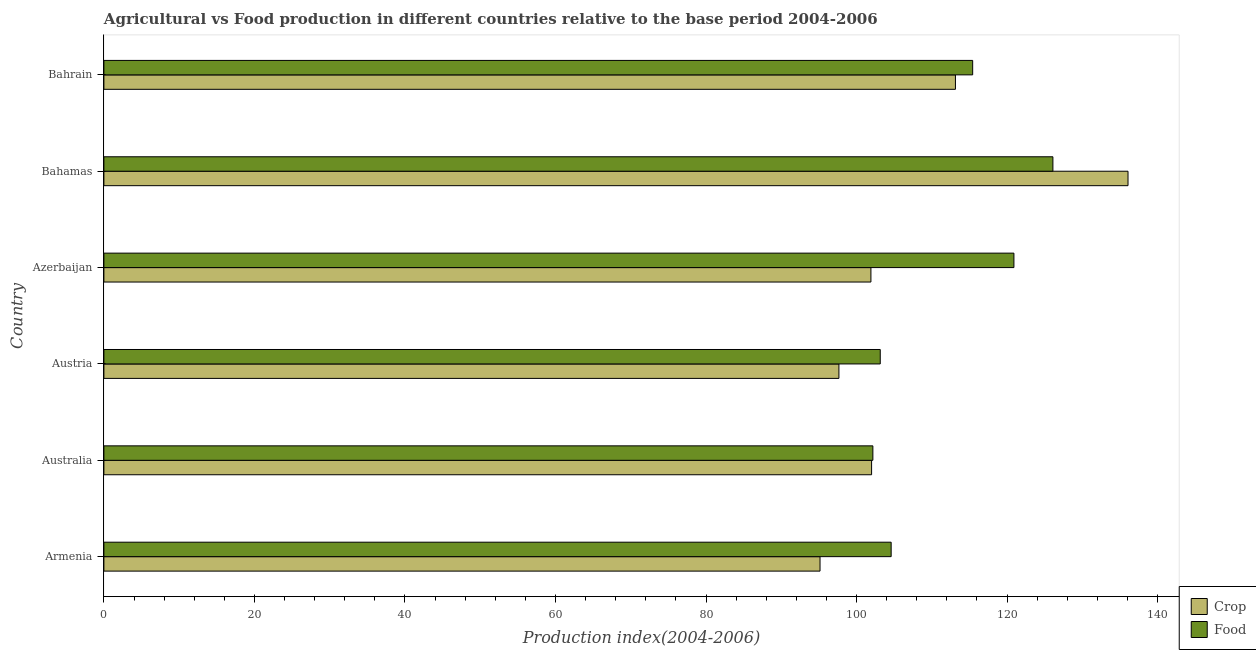Are the number of bars per tick equal to the number of legend labels?
Provide a short and direct response. Yes. Are the number of bars on each tick of the Y-axis equal?
Your answer should be compact. Yes. How many bars are there on the 1st tick from the bottom?
Your answer should be very brief. 2. What is the label of the 3rd group of bars from the top?
Your answer should be compact. Azerbaijan. In how many cases, is the number of bars for a given country not equal to the number of legend labels?
Ensure brevity in your answer.  0. What is the food production index in Austria?
Give a very brief answer. 103.15. Across all countries, what is the maximum food production index?
Provide a succinct answer. 126.09. Across all countries, what is the minimum food production index?
Offer a terse response. 102.17. In which country was the crop production index maximum?
Your answer should be very brief. Bahamas. What is the total food production index in the graph?
Your answer should be compact. 672.35. What is the difference between the food production index in Armenia and that in Azerbaijan?
Make the answer very short. -16.31. What is the difference between the food production index in Austria and the crop production index in Bahamas?
Keep it short and to the point. -32.92. What is the average food production index per country?
Provide a succinct answer. 112.06. What is the difference between the crop production index and food production index in Australia?
Ensure brevity in your answer.  -0.17. What is the ratio of the food production index in Azerbaijan to that in Bahrain?
Your answer should be compact. 1.05. Is the food production index in Austria less than that in Bahamas?
Your response must be concise. Yes. Is the difference between the food production index in Azerbaijan and Bahamas greater than the difference between the crop production index in Azerbaijan and Bahamas?
Your answer should be compact. Yes. What is the difference between the highest and the second highest crop production index?
Make the answer very short. 22.93. What is the difference between the highest and the lowest crop production index?
Give a very brief answer. 40.92. What does the 2nd bar from the top in Bahrain represents?
Offer a terse response. Crop. What does the 1st bar from the bottom in Armenia represents?
Offer a terse response. Crop. How many countries are there in the graph?
Your answer should be compact. 6. What is the difference between two consecutive major ticks on the X-axis?
Make the answer very short. 20. Are the values on the major ticks of X-axis written in scientific E-notation?
Make the answer very short. No. Does the graph contain any zero values?
Provide a succinct answer. No. Does the graph contain grids?
Offer a terse response. No. How are the legend labels stacked?
Offer a very short reply. Vertical. What is the title of the graph?
Ensure brevity in your answer.  Agricultural vs Food production in different countries relative to the base period 2004-2006. Does "Total Population" appear as one of the legend labels in the graph?
Provide a succinct answer. No. What is the label or title of the X-axis?
Offer a very short reply. Production index(2004-2006). What is the Production index(2004-2006) in Crop in Armenia?
Your answer should be compact. 95.15. What is the Production index(2004-2006) of Food in Armenia?
Ensure brevity in your answer.  104.6. What is the Production index(2004-2006) of Crop in Australia?
Keep it short and to the point. 102. What is the Production index(2004-2006) of Food in Australia?
Make the answer very short. 102.17. What is the Production index(2004-2006) in Crop in Austria?
Your answer should be compact. 97.66. What is the Production index(2004-2006) in Food in Austria?
Offer a terse response. 103.15. What is the Production index(2004-2006) in Crop in Azerbaijan?
Offer a terse response. 101.91. What is the Production index(2004-2006) of Food in Azerbaijan?
Give a very brief answer. 120.91. What is the Production index(2004-2006) of Crop in Bahamas?
Keep it short and to the point. 136.07. What is the Production index(2004-2006) in Food in Bahamas?
Make the answer very short. 126.09. What is the Production index(2004-2006) of Crop in Bahrain?
Your answer should be very brief. 113.14. What is the Production index(2004-2006) of Food in Bahrain?
Your answer should be compact. 115.43. Across all countries, what is the maximum Production index(2004-2006) of Crop?
Make the answer very short. 136.07. Across all countries, what is the maximum Production index(2004-2006) in Food?
Provide a short and direct response. 126.09. Across all countries, what is the minimum Production index(2004-2006) of Crop?
Offer a terse response. 95.15. Across all countries, what is the minimum Production index(2004-2006) of Food?
Make the answer very short. 102.17. What is the total Production index(2004-2006) in Crop in the graph?
Offer a terse response. 645.93. What is the total Production index(2004-2006) of Food in the graph?
Your response must be concise. 672.35. What is the difference between the Production index(2004-2006) of Crop in Armenia and that in Australia?
Your response must be concise. -6.85. What is the difference between the Production index(2004-2006) of Food in Armenia and that in Australia?
Offer a very short reply. 2.43. What is the difference between the Production index(2004-2006) in Crop in Armenia and that in Austria?
Provide a succinct answer. -2.51. What is the difference between the Production index(2004-2006) in Food in Armenia and that in Austria?
Your answer should be very brief. 1.45. What is the difference between the Production index(2004-2006) in Crop in Armenia and that in Azerbaijan?
Your answer should be compact. -6.76. What is the difference between the Production index(2004-2006) of Food in Armenia and that in Azerbaijan?
Provide a short and direct response. -16.31. What is the difference between the Production index(2004-2006) of Crop in Armenia and that in Bahamas?
Your answer should be very brief. -40.92. What is the difference between the Production index(2004-2006) of Food in Armenia and that in Bahamas?
Your answer should be very brief. -21.49. What is the difference between the Production index(2004-2006) of Crop in Armenia and that in Bahrain?
Your response must be concise. -17.99. What is the difference between the Production index(2004-2006) of Food in Armenia and that in Bahrain?
Your response must be concise. -10.83. What is the difference between the Production index(2004-2006) of Crop in Australia and that in Austria?
Offer a terse response. 4.34. What is the difference between the Production index(2004-2006) of Food in Australia and that in Austria?
Make the answer very short. -0.98. What is the difference between the Production index(2004-2006) in Crop in Australia and that in Azerbaijan?
Make the answer very short. 0.09. What is the difference between the Production index(2004-2006) in Food in Australia and that in Azerbaijan?
Your answer should be compact. -18.74. What is the difference between the Production index(2004-2006) of Crop in Australia and that in Bahamas?
Give a very brief answer. -34.07. What is the difference between the Production index(2004-2006) of Food in Australia and that in Bahamas?
Your answer should be compact. -23.92. What is the difference between the Production index(2004-2006) in Crop in Australia and that in Bahrain?
Your answer should be compact. -11.14. What is the difference between the Production index(2004-2006) in Food in Australia and that in Bahrain?
Provide a succinct answer. -13.26. What is the difference between the Production index(2004-2006) in Crop in Austria and that in Azerbaijan?
Ensure brevity in your answer.  -4.25. What is the difference between the Production index(2004-2006) of Food in Austria and that in Azerbaijan?
Offer a terse response. -17.76. What is the difference between the Production index(2004-2006) of Crop in Austria and that in Bahamas?
Give a very brief answer. -38.41. What is the difference between the Production index(2004-2006) in Food in Austria and that in Bahamas?
Your answer should be compact. -22.94. What is the difference between the Production index(2004-2006) of Crop in Austria and that in Bahrain?
Provide a succinct answer. -15.48. What is the difference between the Production index(2004-2006) of Food in Austria and that in Bahrain?
Offer a terse response. -12.28. What is the difference between the Production index(2004-2006) of Crop in Azerbaijan and that in Bahamas?
Provide a succinct answer. -34.16. What is the difference between the Production index(2004-2006) in Food in Azerbaijan and that in Bahamas?
Ensure brevity in your answer.  -5.18. What is the difference between the Production index(2004-2006) of Crop in Azerbaijan and that in Bahrain?
Offer a very short reply. -11.23. What is the difference between the Production index(2004-2006) in Food in Azerbaijan and that in Bahrain?
Your answer should be very brief. 5.48. What is the difference between the Production index(2004-2006) of Crop in Bahamas and that in Bahrain?
Offer a very short reply. 22.93. What is the difference between the Production index(2004-2006) in Food in Bahamas and that in Bahrain?
Keep it short and to the point. 10.66. What is the difference between the Production index(2004-2006) of Crop in Armenia and the Production index(2004-2006) of Food in Australia?
Your answer should be compact. -7.02. What is the difference between the Production index(2004-2006) in Crop in Armenia and the Production index(2004-2006) in Food in Azerbaijan?
Keep it short and to the point. -25.76. What is the difference between the Production index(2004-2006) in Crop in Armenia and the Production index(2004-2006) in Food in Bahamas?
Make the answer very short. -30.94. What is the difference between the Production index(2004-2006) of Crop in Armenia and the Production index(2004-2006) of Food in Bahrain?
Give a very brief answer. -20.28. What is the difference between the Production index(2004-2006) in Crop in Australia and the Production index(2004-2006) in Food in Austria?
Your response must be concise. -1.15. What is the difference between the Production index(2004-2006) in Crop in Australia and the Production index(2004-2006) in Food in Azerbaijan?
Provide a succinct answer. -18.91. What is the difference between the Production index(2004-2006) of Crop in Australia and the Production index(2004-2006) of Food in Bahamas?
Your answer should be very brief. -24.09. What is the difference between the Production index(2004-2006) of Crop in Australia and the Production index(2004-2006) of Food in Bahrain?
Keep it short and to the point. -13.43. What is the difference between the Production index(2004-2006) of Crop in Austria and the Production index(2004-2006) of Food in Azerbaijan?
Offer a terse response. -23.25. What is the difference between the Production index(2004-2006) in Crop in Austria and the Production index(2004-2006) in Food in Bahamas?
Your answer should be compact. -28.43. What is the difference between the Production index(2004-2006) of Crop in Austria and the Production index(2004-2006) of Food in Bahrain?
Give a very brief answer. -17.77. What is the difference between the Production index(2004-2006) of Crop in Azerbaijan and the Production index(2004-2006) of Food in Bahamas?
Give a very brief answer. -24.18. What is the difference between the Production index(2004-2006) of Crop in Azerbaijan and the Production index(2004-2006) of Food in Bahrain?
Make the answer very short. -13.52. What is the difference between the Production index(2004-2006) in Crop in Bahamas and the Production index(2004-2006) in Food in Bahrain?
Your response must be concise. 20.64. What is the average Production index(2004-2006) of Crop per country?
Your response must be concise. 107.66. What is the average Production index(2004-2006) in Food per country?
Make the answer very short. 112.06. What is the difference between the Production index(2004-2006) in Crop and Production index(2004-2006) in Food in Armenia?
Your answer should be very brief. -9.45. What is the difference between the Production index(2004-2006) in Crop and Production index(2004-2006) in Food in Australia?
Keep it short and to the point. -0.17. What is the difference between the Production index(2004-2006) of Crop and Production index(2004-2006) of Food in Austria?
Your answer should be very brief. -5.49. What is the difference between the Production index(2004-2006) of Crop and Production index(2004-2006) of Food in Azerbaijan?
Ensure brevity in your answer.  -19. What is the difference between the Production index(2004-2006) of Crop and Production index(2004-2006) of Food in Bahamas?
Your answer should be very brief. 9.98. What is the difference between the Production index(2004-2006) in Crop and Production index(2004-2006) in Food in Bahrain?
Your response must be concise. -2.29. What is the ratio of the Production index(2004-2006) in Crop in Armenia to that in Australia?
Give a very brief answer. 0.93. What is the ratio of the Production index(2004-2006) of Food in Armenia to that in Australia?
Provide a succinct answer. 1.02. What is the ratio of the Production index(2004-2006) of Crop in Armenia to that in Austria?
Offer a very short reply. 0.97. What is the ratio of the Production index(2004-2006) of Food in Armenia to that in Austria?
Your response must be concise. 1.01. What is the ratio of the Production index(2004-2006) in Crop in Armenia to that in Azerbaijan?
Your answer should be very brief. 0.93. What is the ratio of the Production index(2004-2006) in Food in Armenia to that in Azerbaijan?
Provide a succinct answer. 0.87. What is the ratio of the Production index(2004-2006) of Crop in Armenia to that in Bahamas?
Provide a succinct answer. 0.7. What is the ratio of the Production index(2004-2006) of Food in Armenia to that in Bahamas?
Offer a very short reply. 0.83. What is the ratio of the Production index(2004-2006) of Crop in Armenia to that in Bahrain?
Offer a terse response. 0.84. What is the ratio of the Production index(2004-2006) of Food in Armenia to that in Bahrain?
Your answer should be compact. 0.91. What is the ratio of the Production index(2004-2006) of Crop in Australia to that in Austria?
Provide a short and direct response. 1.04. What is the ratio of the Production index(2004-2006) in Crop in Australia to that in Azerbaijan?
Keep it short and to the point. 1. What is the ratio of the Production index(2004-2006) in Food in Australia to that in Azerbaijan?
Provide a succinct answer. 0.84. What is the ratio of the Production index(2004-2006) in Crop in Australia to that in Bahamas?
Provide a succinct answer. 0.75. What is the ratio of the Production index(2004-2006) in Food in Australia to that in Bahamas?
Your answer should be very brief. 0.81. What is the ratio of the Production index(2004-2006) of Crop in Australia to that in Bahrain?
Offer a terse response. 0.9. What is the ratio of the Production index(2004-2006) in Food in Australia to that in Bahrain?
Ensure brevity in your answer.  0.89. What is the ratio of the Production index(2004-2006) in Food in Austria to that in Azerbaijan?
Provide a succinct answer. 0.85. What is the ratio of the Production index(2004-2006) of Crop in Austria to that in Bahamas?
Your answer should be compact. 0.72. What is the ratio of the Production index(2004-2006) in Food in Austria to that in Bahamas?
Provide a short and direct response. 0.82. What is the ratio of the Production index(2004-2006) in Crop in Austria to that in Bahrain?
Make the answer very short. 0.86. What is the ratio of the Production index(2004-2006) in Food in Austria to that in Bahrain?
Your answer should be compact. 0.89. What is the ratio of the Production index(2004-2006) of Crop in Azerbaijan to that in Bahamas?
Ensure brevity in your answer.  0.75. What is the ratio of the Production index(2004-2006) in Food in Azerbaijan to that in Bahamas?
Offer a very short reply. 0.96. What is the ratio of the Production index(2004-2006) in Crop in Azerbaijan to that in Bahrain?
Offer a terse response. 0.9. What is the ratio of the Production index(2004-2006) in Food in Azerbaijan to that in Bahrain?
Give a very brief answer. 1.05. What is the ratio of the Production index(2004-2006) in Crop in Bahamas to that in Bahrain?
Make the answer very short. 1.2. What is the ratio of the Production index(2004-2006) of Food in Bahamas to that in Bahrain?
Keep it short and to the point. 1.09. What is the difference between the highest and the second highest Production index(2004-2006) in Crop?
Your response must be concise. 22.93. What is the difference between the highest and the second highest Production index(2004-2006) of Food?
Your answer should be very brief. 5.18. What is the difference between the highest and the lowest Production index(2004-2006) of Crop?
Ensure brevity in your answer.  40.92. What is the difference between the highest and the lowest Production index(2004-2006) of Food?
Your response must be concise. 23.92. 